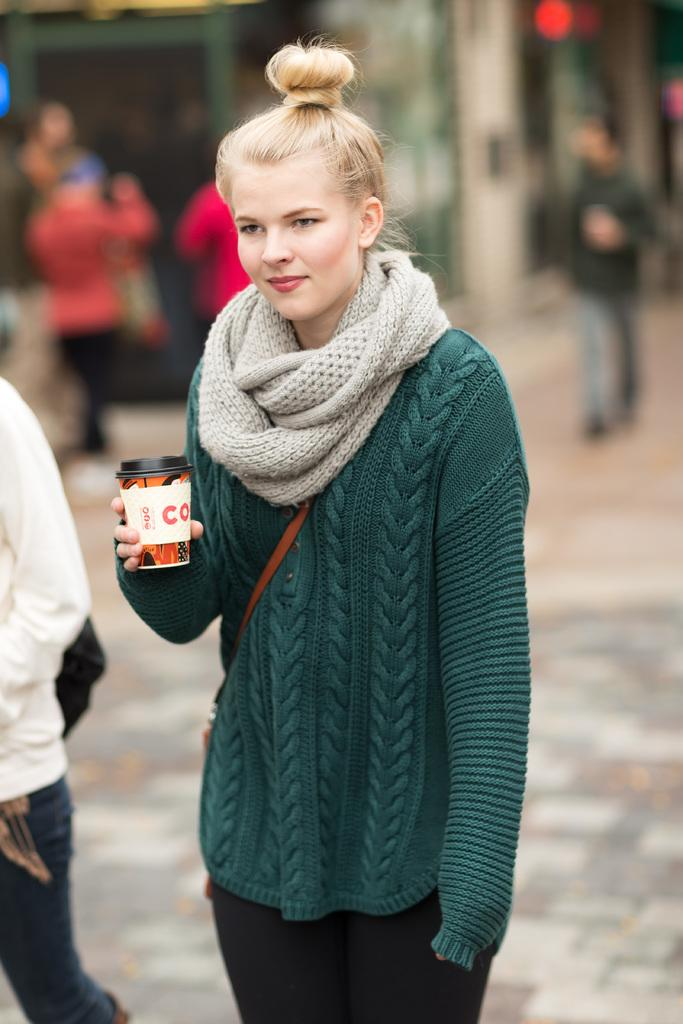Who is the main subject in the image? There is a lady in the image. What is the lady doing in the image? The lady is standing on a pavement and holding a cup in her hand. What can be seen in the background of the image? There are people walking in the background of the image, and the background is blurred. What type of animal is the lady riding in the image? There is no animal present in the image, and the lady is not riding anything. What type of education does the lady have, as depicted in the image? The image does not provide any information about the lady's education. 